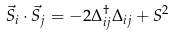<formula> <loc_0><loc_0><loc_500><loc_500>\vec { S } _ { i } \cdot \vec { S } _ { j } = - 2 \Delta _ { i j } ^ { \dagger } \Delta _ { i j } + S ^ { 2 }</formula> 